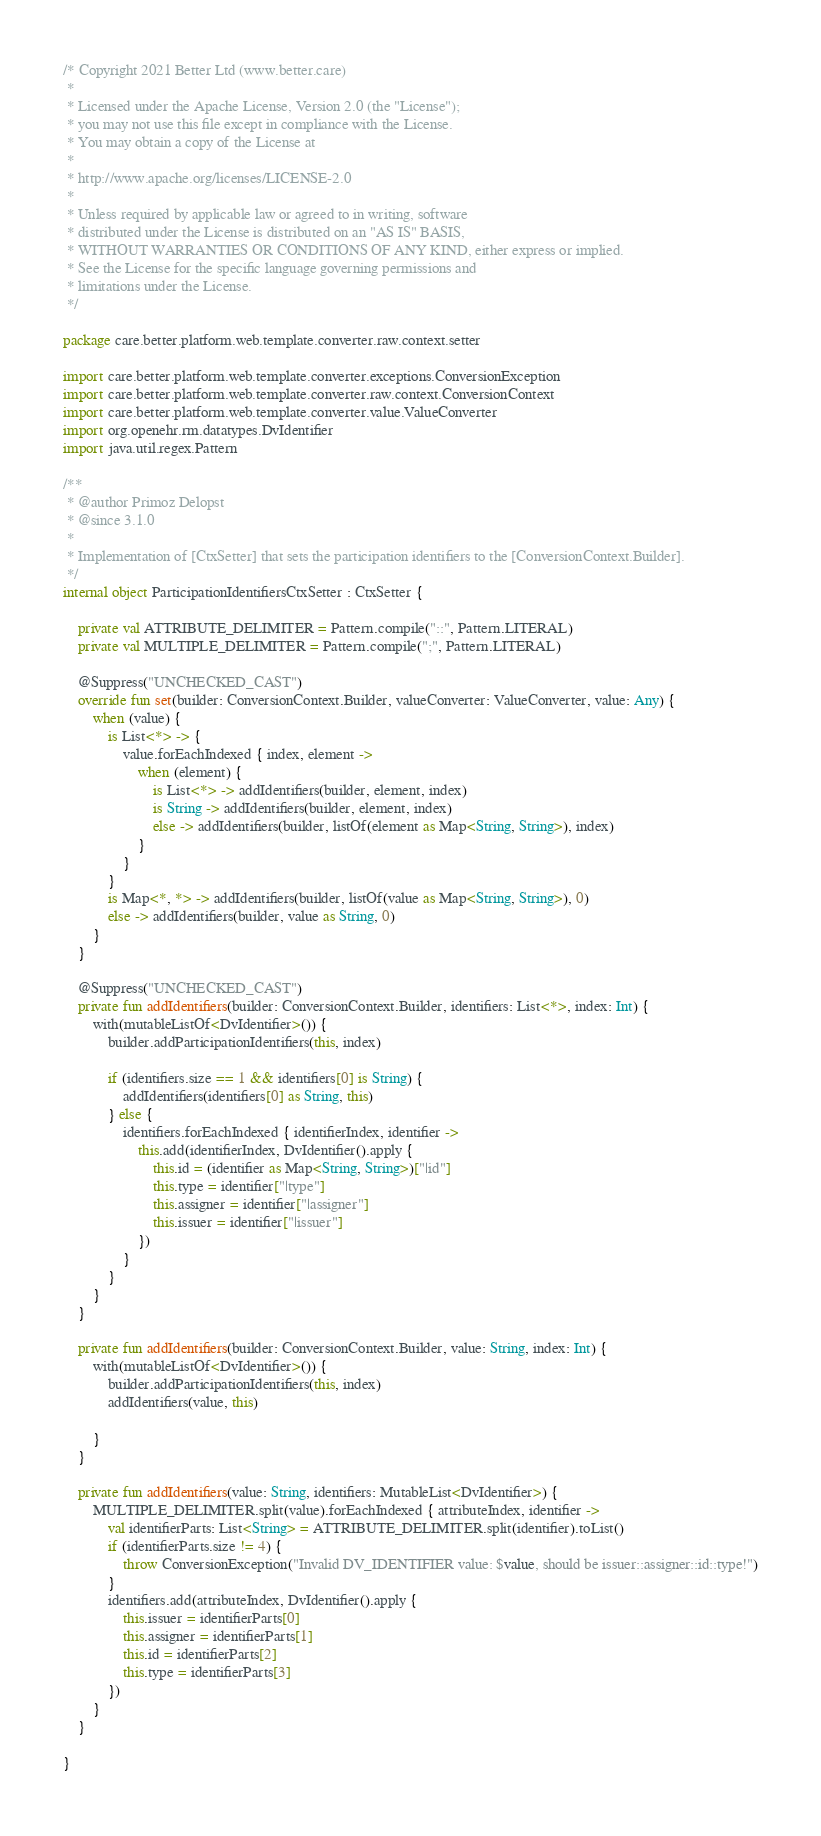<code> <loc_0><loc_0><loc_500><loc_500><_Kotlin_>/* Copyright 2021 Better Ltd (www.better.care)
 *
 * Licensed under the Apache License, Version 2.0 (the "License");
 * you may not use this file except in compliance with the License.
 * You may obtain a copy of the License at
 *
 * http://www.apache.org/licenses/LICENSE-2.0
 *
 * Unless required by applicable law or agreed to in writing, software
 * distributed under the License is distributed on an "AS IS" BASIS,
 * WITHOUT WARRANTIES OR CONDITIONS OF ANY KIND, either express or implied.
 * See the License for the specific language governing permissions and
 * limitations under the License.
 */

package care.better.platform.web.template.converter.raw.context.setter

import care.better.platform.web.template.converter.exceptions.ConversionException
import care.better.platform.web.template.converter.raw.context.ConversionContext
import care.better.platform.web.template.converter.value.ValueConverter
import org.openehr.rm.datatypes.DvIdentifier
import java.util.regex.Pattern

/**
 * @author Primoz Delopst
 * @since 3.1.0
 *
 * Implementation of [CtxSetter] that sets the participation identifiers to the [ConversionContext.Builder].
 */
internal object ParticipationIdentifiersCtxSetter : CtxSetter {

    private val ATTRIBUTE_DELIMITER = Pattern.compile("::", Pattern.LITERAL)
    private val MULTIPLE_DELIMITER = Pattern.compile(";", Pattern.LITERAL)

    @Suppress("UNCHECKED_CAST")
    override fun set(builder: ConversionContext.Builder, valueConverter: ValueConverter, value: Any) {
        when (value) {
            is List<*> -> {
                value.forEachIndexed { index, element ->
                    when (element) {
                        is List<*> -> addIdentifiers(builder, element, index)
                        is String -> addIdentifiers(builder, element, index)
                        else -> addIdentifiers(builder, listOf(element as Map<String, String>), index)
                    }
                }
            }
            is Map<*, *> -> addIdentifiers(builder, listOf(value as Map<String, String>), 0)
            else -> addIdentifiers(builder, value as String, 0)
        }
    }

    @Suppress("UNCHECKED_CAST")
    private fun addIdentifiers(builder: ConversionContext.Builder, identifiers: List<*>, index: Int) {
        with(mutableListOf<DvIdentifier>()) {
            builder.addParticipationIdentifiers(this, index)

            if (identifiers.size == 1 && identifiers[0] is String) {
                addIdentifiers(identifiers[0] as String, this)
            } else {
                identifiers.forEachIndexed { identifierIndex, identifier ->
                    this.add(identifierIndex, DvIdentifier().apply {
                        this.id = (identifier as Map<String, String>)["|id"]
                        this.type = identifier["|type"]
                        this.assigner = identifier["|assigner"]
                        this.issuer = identifier["|issuer"]
                    })
                }
            }
        }
    }

    private fun addIdentifiers(builder: ConversionContext.Builder, value: String, index: Int) {
        with(mutableListOf<DvIdentifier>()) {
            builder.addParticipationIdentifiers(this, index)
            addIdentifiers(value, this)

        }
    }

    private fun addIdentifiers(value: String, identifiers: MutableList<DvIdentifier>) {
        MULTIPLE_DELIMITER.split(value).forEachIndexed { attributeIndex, identifier ->
            val identifierParts: List<String> = ATTRIBUTE_DELIMITER.split(identifier).toList()
            if (identifierParts.size != 4) {
                throw ConversionException("Invalid DV_IDENTIFIER value: $value, should be issuer::assigner::id::type!")
            }
            identifiers.add(attributeIndex, DvIdentifier().apply {
                this.issuer = identifierParts[0]
                this.assigner = identifierParts[1]
                this.id = identifierParts[2]
                this.type = identifierParts[3]
            })
        }
    }

}
</code> 